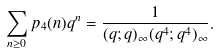Convert formula to latex. <formula><loc_0><loc_0><loc_500><loc_500>\sum _ { n \geq 0 } p _ { 4 } ( n ) q ^ { n } = \frac { 1 } { ( q ; q ) _ { \infty } ( q ^ { 4 } ; q ^ { 4 } ) _ { \infty } } .</formula> 